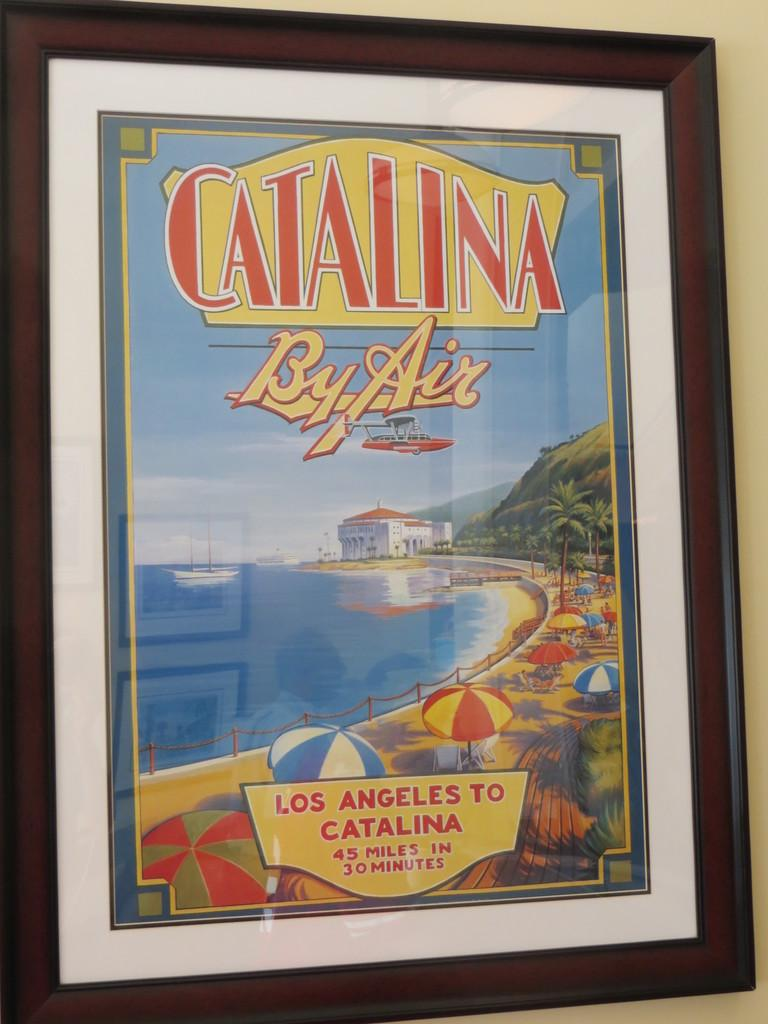What is the main subject of the image? The main subject of the image is a frame of a poster. Where is the frame located in the image? The frame is placed on a wall. What type of toys can be seen in the image? There are no toys present in the image; it only features a frame of a poster on a wall. What event is taking place in the image? There is no event taking place in the image; it simply shows a framed poster on a wall. 